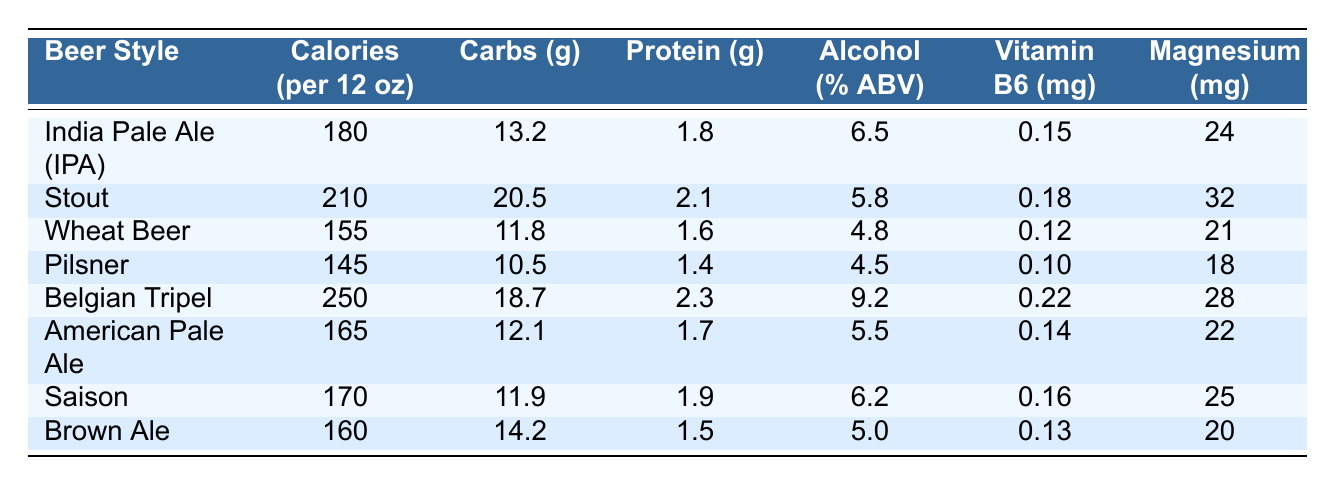What is the beer style with the highest calorie content? The table shows that the Belgian Tripel has the highest calorie content at 250 calories per 12 oz.
Answer: Belgian Tripel How many carbohydrates are there in a Pilsner? According to the table, a Pilsner contains 10.5 grams of carbohydrates.
Answer: 10.5 grams Which beer style has the lowest amount of protein? The Wheat Beer has the lowest amount of protein with 1.6 grams, as shown in the table.
Answer: Wheat Beer What is the average alcohol percentage among these beer styles? The total alcohol percentages of all the beer styles are (6.5 + 5.8 + 4.8 + 4.5 + 9.2 + 5.5 + 6.2 + 5.0) = 47.5. Since there are 8 styles, the average is 47.5 / 8 = 5.9375, which rounds to approximately 5.94%.
Answer: 5.94% Is it true that the Stout has more carbohydrates than the American Pale Ale? The Stout has 20.5 grams of carbohydrates, while the American Pale Ale has 12.1 grams. Since 20.5 is greater than 12.1, this statement is true.
Answer: Yes Which beer styles have more than 20 mg of magnesium? The Stout has 32 mg, the Belgian Tripel has 28 mg, and Saison has 25 mg. So, these three beer styles have more than 20 mg of magnesium.
Answer: Stout, Belgian Tripel, Saison What is the difference in calories between the Stout and the Pilsner? The Stout has 210 calories and the Pilsner has 145 calories. The difference is 210 - 145 = 65 calories.
Answer: 65 calories Which beer style has the highest content of Vitamin B6? The Belgian Tripel has the highest content of Vitamin B6 with 0.22 mg, according to the table.
Answer: Belgian Tripel How does the carbohydrate content of the IPA compare to the average carbohydrate content of all listed beers? The total carbohydrates of all styles are (13.2 + 20.5 + 11.8 + 10.5 + 18.7 + 12.1 + 11.9 + 14.2) = 132.9 grams. The average carbohydrate content is 132.9 / 8 = 16.6125 grams. Compared to the IPA's 13.2 grams, the IPA is lower than the average.
Answer: Lower than average Which beer styles have an alcohol content percentage above 6%? The styles with an alcohol content above 6% are India Pale Ale (6.5%), Belgian Tripel (9.2%), and Saison (6.2%).
Answer: IPA, Belgian Tripel, Saison 